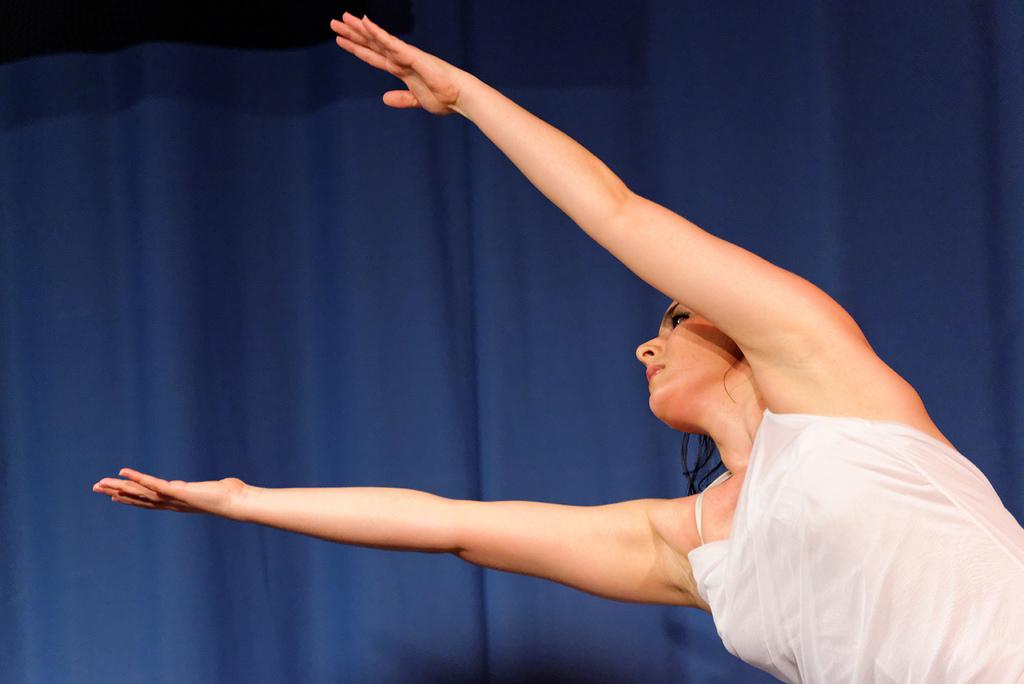Who is the main subject in the image? There is a lady in the center of the image. What can be seen in the background of the image? There is a curtain in the background of the image. What type of swimwear is the lady wearing in the image? There is no swimwear visible in the image; the lady is not depicted in a swimming context. 